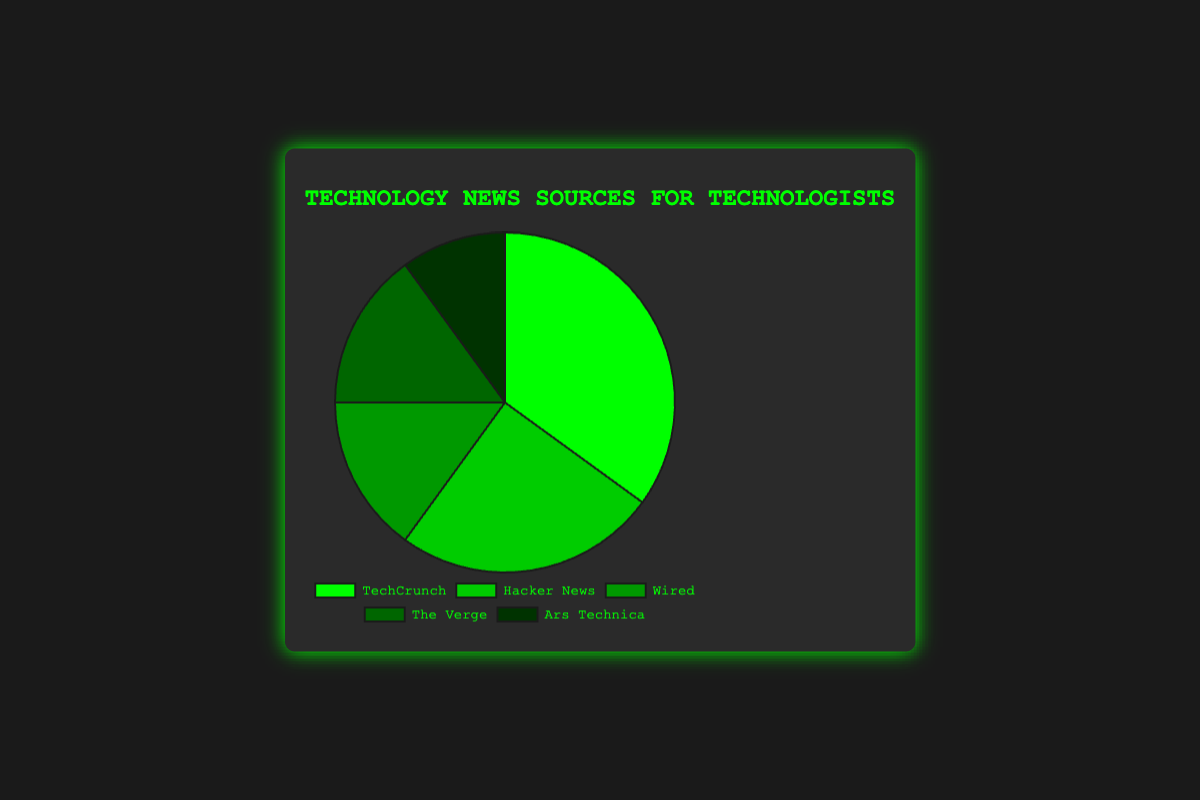What is the most popular news source among technologists? The most popular news source is identified by the highest percentage segment in the pie chart. In this case, TechCrunch has the highest percentage, 35%.
Answer: TechCrunch How much more popular is TechCrunch compared to Ars Technica? The difference in popularity is the percentage of TechCrunch minus the percentage of Ars Technica: 35% - 10% = 25%.
Answer: 25% What percentage of technologists rely on Wired and The Verge combined? The combined percentage is the sum of the percentages for Wired and The Verge: 15% + 15% = 30%.
Answer: 30% Which news sources have the same percentage of consumers? The pie chart shows that Wired and The Verge each have a percentage of 15%.
Answer: Wired and The Verge What is the average percentage of the top three news sources? First, identify the top three sources: TechCrunch (35%), Hacker News (25%), and Wired (15%). Then calculate the average: (35% + 25% + 15%) / 3 = 75% / 3 = 25%.
Answer: 25% How does the popularity of Hacker News compare to Wired? Hacker News has a higher percentage than Wired. Hacker News is 25%, while Wired is 15%.
Answer: Higher What is the combined percentage for sources other than TechCrunch? Combine the percentages of Hacker News, Wired, The Verge, and Ars Technica: 25% + 15% + 15% + 10% = 65%.
Answer: 65% Which source has the least percentage and what is it? Observing the pie chart, the source with the smallest segment is Ars Technica with 10%.
Answer: Ars Technica, 10% Is the total percentage of Hacker News and Ars Technica greater than TechCrunch? Calculate the combined percentage of Hacker News and Ars Technica: 25% + 10% = 35%. Since 35% is equal to the percentage for TechCrunch, they are not greater.
Answer: No What is the difference between the most and least popular sources? The difference is found by subtracting the percentage of Ars Technica from the percentage of TechCrunch: 35% - 10% = 25%.
Answer: 25% 